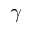Convert formula to latex. <formula><loc_0><loc_0><loc_500><loc_500>\gamma</formula> 